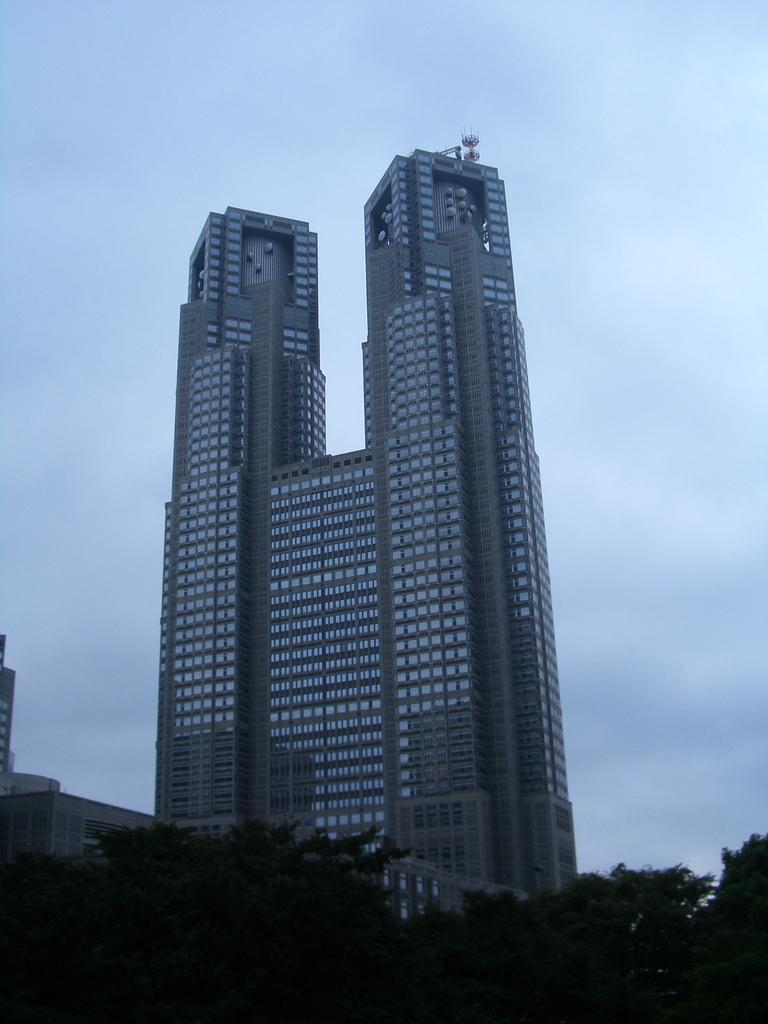What type of vegetation is at the bottom of the image? There are trees at the bottom of the image. What can be seen in the distance in the image? There are buildings in the background of the image. What feature is visible on the buildings? There are windows visible in the image. What is present on the buildings? There are items on the buildings. What is visible in the sky in the image? Clouds are present in the sky. What type of faucet is visible on the trees in the image? There is no faucet present on the trees in the image. What type of leather is visible on the buildings in the image? There is no leather present on the buildings in the image. 